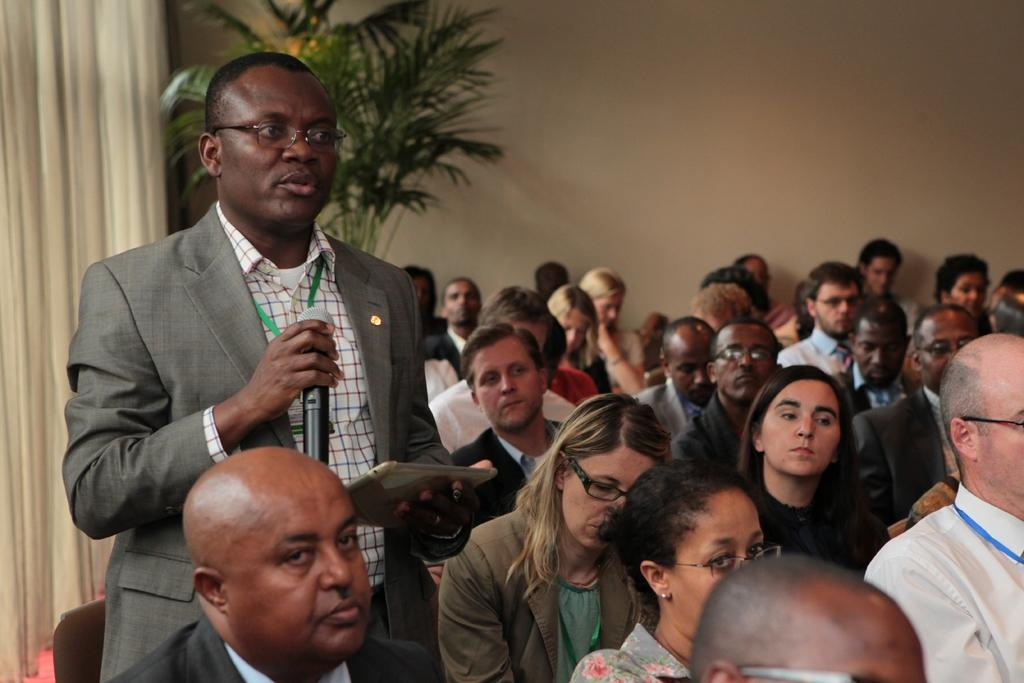What is the main subject of the image? There is a crowd in the image. Can you describe the man standing in the image? The man is holding a mic in one hand and a tablet in the other hand. What can be seen in the background of the image? There is a curtain, a houseplant, and walls visible in the background of the image. How does the gate open in the image? There is no gate present in the image. What type of swing can be seen in the image? There is no swing present in the image. 